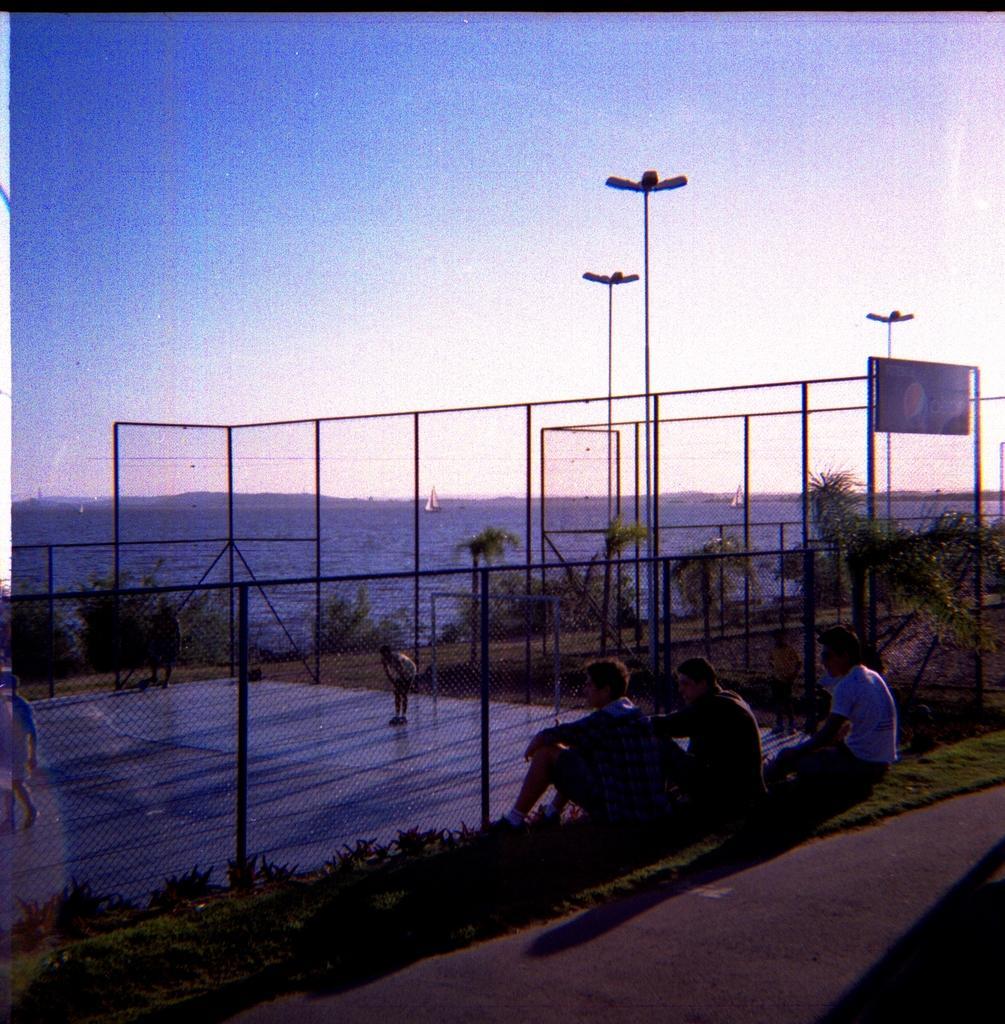Could you give a brief overview of what you see in this image? There are three persons sitting on grass and we can see mesh,through this mesh we can see persons and we can see board and lights on poles. On the background we can see trees,boats on water and sky. 